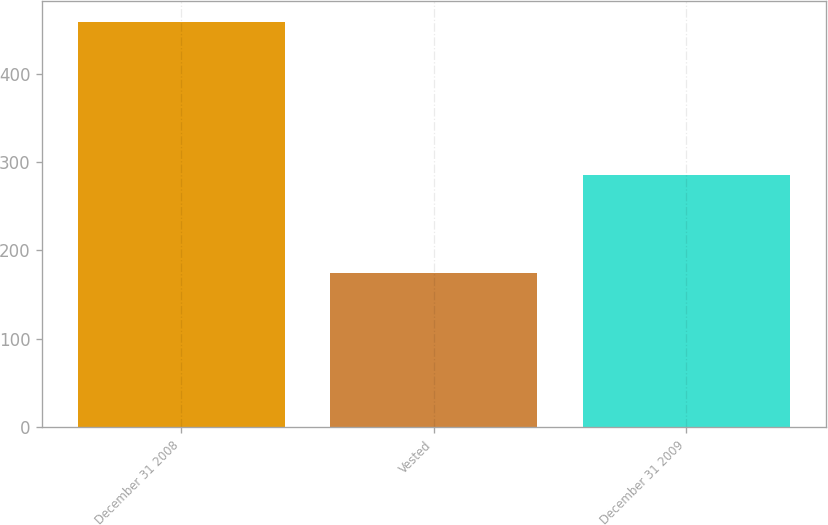<chart> <loc_0><loc_0><loc_500><loc_500><bar_chart><fcel>December 31 2008<fcel>Vested<fcel>December 31 2009<nl><fcel>459<fcel>174<fcel>285<nl></chart> 